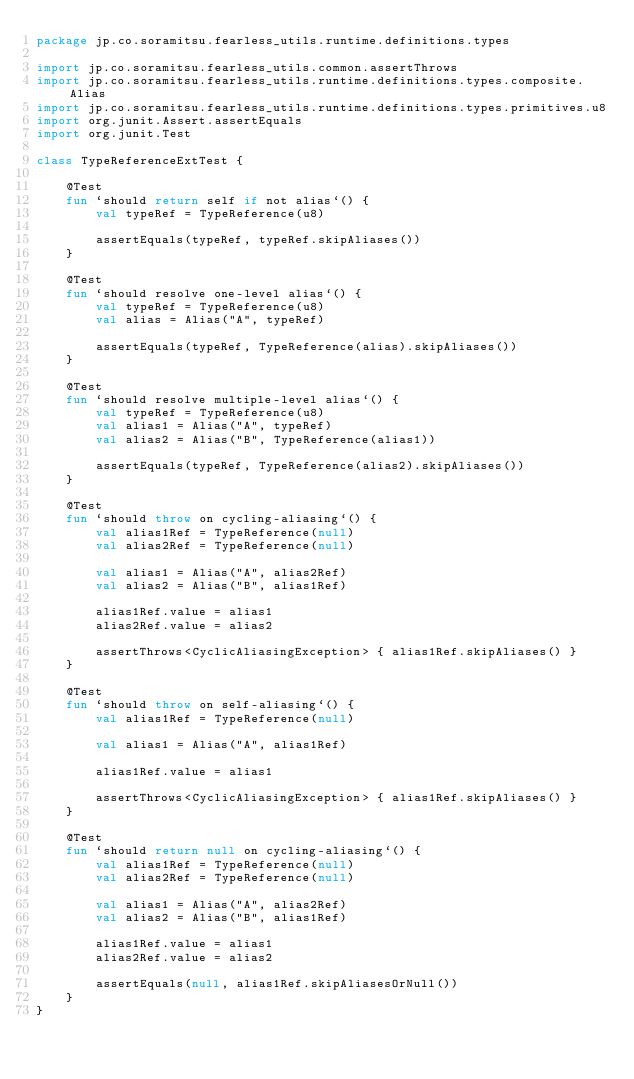<code> <loc_0><loc_0><loc_500><loc_500><_Kotlin_>package jp.co.soramitsu.fearless_utils.runtime.definitions.types

import jp.co.soramitsu.fearless_utils.common.assertThrows
import jp.co.soramitsu.fearless_utils.runtime.definitions.types.composite.Alias
import jp.co.soramitsu.fearless_utils.runtime.definitions.types.primitives.u8
import org.junit.Assert.assertEquals
import org.junit.Test

class TypeReferenceExtTest {

    @Test
    fun `should return self if not alias`() {
        val typeRef = TypeReference(u8)

        assertEquals(typeRef, typeRef.skipAliases())
    }

    @Test
    fun `should resolve one-level alias`() {
        val typeRef = TypeReference(u8)
        val alias = Alias("A", typeRef)

        assertEquals(typeRef, TypeReference(alias).skipAliases())
    }

    @Test
    fun `should resolve multiple-level alias`() {
        val typeRef = TypeReference(u8)
        val alias1 = Alias("A", typeRef)
        val alias2 = Alias("B", TypeReference(alias1))

        assertEquals(typeRef, TypeReference(alias2).skipAliases())
    }

    @Test
    fun `should throw on cycling-aliasing`() {
        val alias1Ref = TypeReference(null)
        val alias2Ref = TypeReference(null)

        val alias1 = Alias("A", alias2Ref)
        val alias2 = Alias("B", alias1Ref)

        alias1Ref.value = alias1
        alias2Ref.value = alias2

        assertThrows<CyclicAliasingException> { alias1Ref.skipAliases() }
    }

    @Test
    fun `should throw on self-aliasing`() {
        val alias1Ref = TypeReference(null)

        val alias1 = Alias("A", alias1Ref)

        alias1Ref.value = alias1

        assertThrows<CyclicAliasingException> { alias1Ref.skipAliases() }
    }

    @Test
    fun `should return null on cycling-aliasing`() {
        val alias1Ref = TypeReference(null)
        val alias2Ref = TypeReference(null)

        val alias1 = Alias("A", alias2Ref)
        val alias2 = Alias("B", alias1Ref)

        alias1Ref.value = alias1
        alias2Ref.value = alias2

        assertEquals(null, alias1Ref.skipAliasesOrNull())
    }
}</code> 